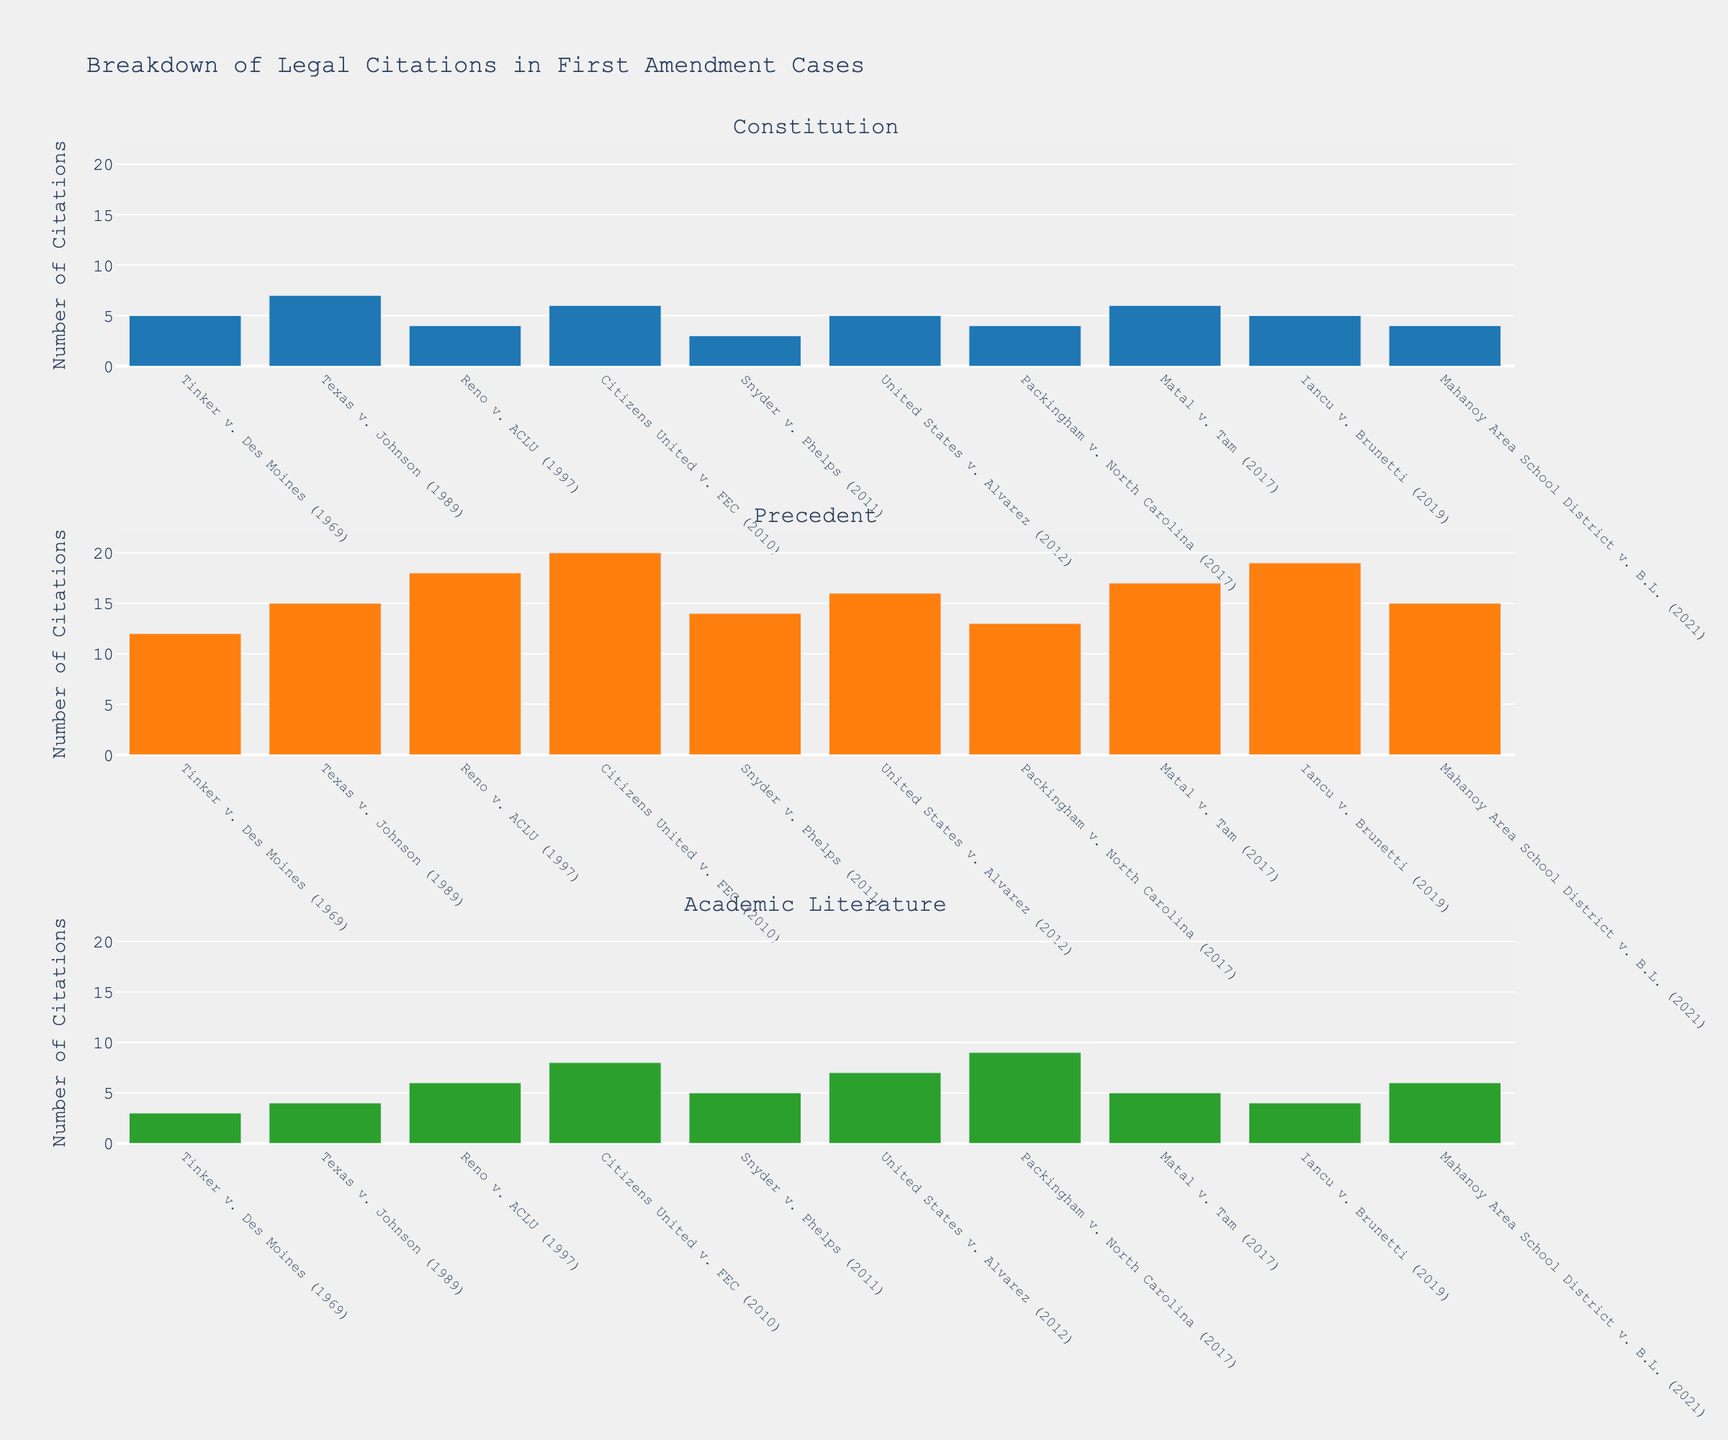What is the title of the figure? The title of the figure can be found at the top, usually in a larger and bold font.
Answer: Breakdown of Legal Citations in First Amendment Cases Which subplot shows the most legal citations in total? Sum the number of citations for each case in each subplot. The subplot with the highest sum represents the category with the most citations. For the Constitution, the sum is 49; for Precedent, the sum is 159; for Academic Literature, the sum is 57.
Answer: Precedent What are the y-axis labels for each subplot? The y-axis labels are the same for all three subplots and can be found along the vertical axis on the left.
Answer: Number of Citations How many cases have more than 15 citations under the Precedent category? Count the bars in the Precedent subplot that exceed the y-axis value of 15. There are five cases: Reno v. ACLU, Citizens United v. FEC, United States v. Alvarez, Matal v. Tam, and Iancu v. Brunetti.
Answer: 5 Which case has the highest number of citations in the Academic Literature category? Look at the bars in the Academic Literature subplot; find the tallest bar and its corresponding case name. Packingham v. North Carolina has 9 citations.
Answer: Packingham v. North Carolina What is the average number of citations in the Constitution category? Add up the number of citations for the Constitution across all cases (5, 7, 4, 6, 3, 5, 4, 6, 5, 4) which sums to 49. There are 10 cases, so the average is 49 / 10.
Answer: 4.9 Compare the number of citations between Tinker v. Des Moines and Citizens United v. FEC in the Academic Literature category. Which one has more, and by how much? In the Academic Literature subplot, Tinker v. Des Moines has 3 citations and Citizens United v. FEC has 8. Subtract the two values to get the difference: 8 - 3.
Answer: Citizens United v. FEC by 5 Which case has the fewest citations in the Constitution category? Look at the bars in the Constitution subplot and find the shortest bar, which corresponds to Snyder v. Phelps with 3 citations.
Answer: Snyder v. Phelps How many total citations are there in the Precedent category for all cases? Sum all the values in the Precedent category (12, 15, 18, 20, 14, 16, 13, 17, 19, 15). The sum is 159.
Answer: 159 What is the difference between citations in the Precedent and Academic Literature categories for the case "Reno v. ACLU"? In the Precedent subplot, Reno v. ACLU has 18 citations, and in the Academic Literature subplot, it has 6. Subtract the two values: 18 - 6.
Answer: 12 